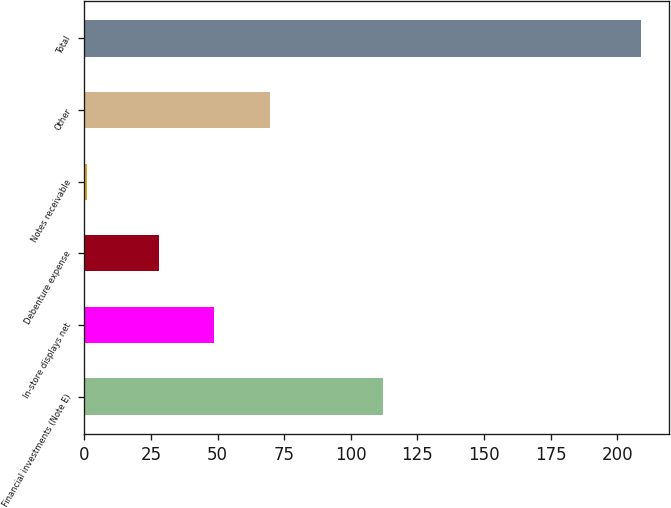Convert chart. <chart><loc_0><loc_0><loc_500><loc_500><bar_chart><fcel>Financial investments (Note E)<fcel>In-store displays net<fcel>Debenture expense<fcel>Notes receivable<fcel>Other<fcel>Total<nl><fcel>112<fcel>48.8<fcel>28<fcel>1<fcel>69.6<fcel>209<nl></chart> 